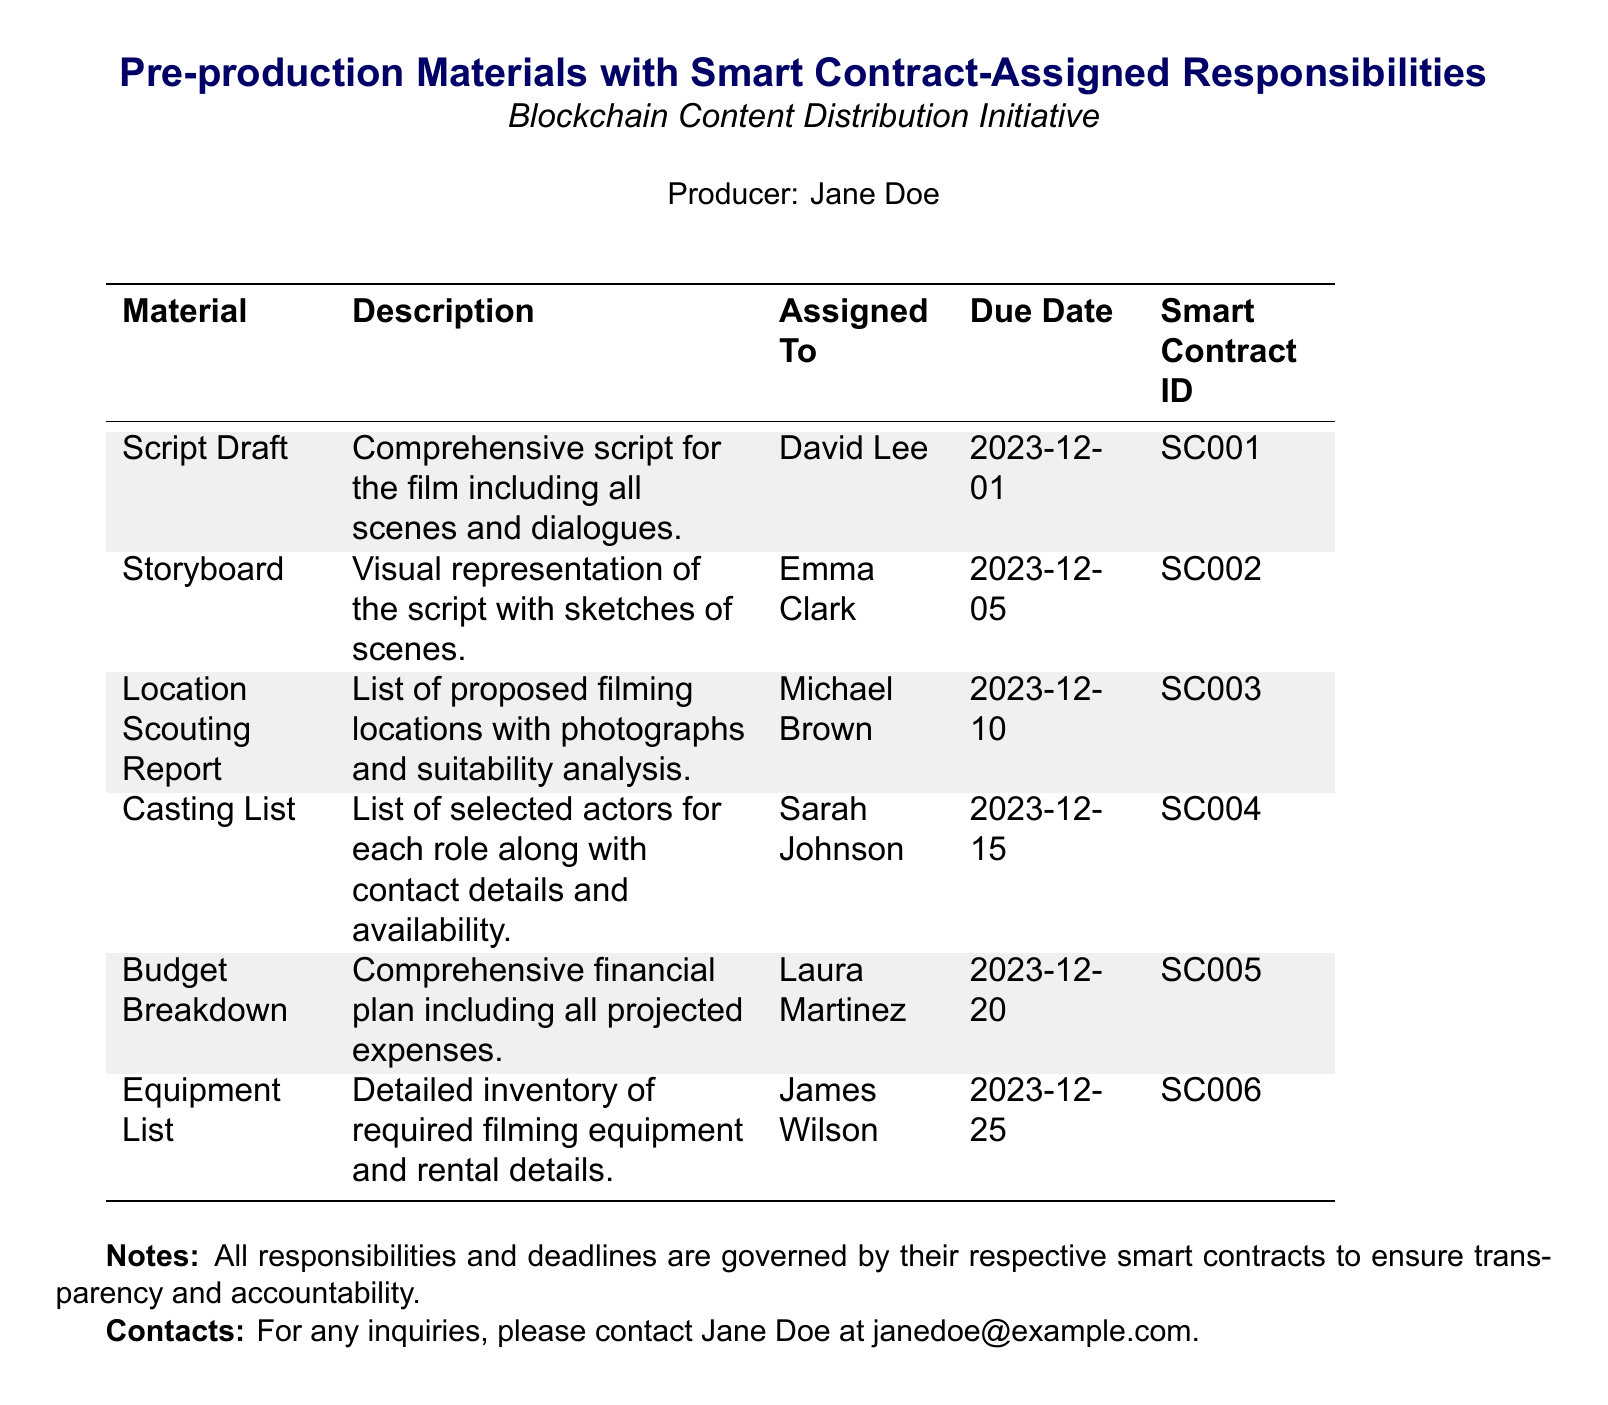What is the due date for the Script Draft? The due date for the Script Draft is specified in the document as the date assigned to this material.
Answer: 2023-12-01 Who is responsible for the Storyboard? The document lists assigned responsibilities where the Storyboard is linked to a specific individual.
Answer: Emma Clark What is the Smart Contract ID for the Budget Breakdown? Each material in the document has a corresponding Smart Contract ID, which can be directly retrieved for the Budget Breakdown.
Answer: SC005 How many days are allocated until the due date of the Casting List from today? This requires calculating the time from the current date to the due date mentioned for the Casting List, indicating a need for arithmetic.
Answer: 45 days Which material is due last? The material with the latest due date indicates which task is scheduled to complete last in the document.
Answer: Equipment List What type of analysis is included in the Location Scouting Report? The Location Scouting Report is described in detail in the document, indicating the type of information contained within it.
Answer: Suitability analysis What is the role of Laura Martinez in the project? The document assigns specific responsibilities to individuals, revealing what role each person plays, particularly in terms of financial planning.
Answer: Budget Breakdown What color is used for the rows in the table? The document designates specific colors to certain rows, creating a visual distinction for the reader.
Answer: Light gray 